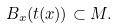Convert formula to latex. <formula><loc_0><loc_0><loc_500><loc_500>B _ { x } ( t ( x ) ) \subset { M } .</formula> 